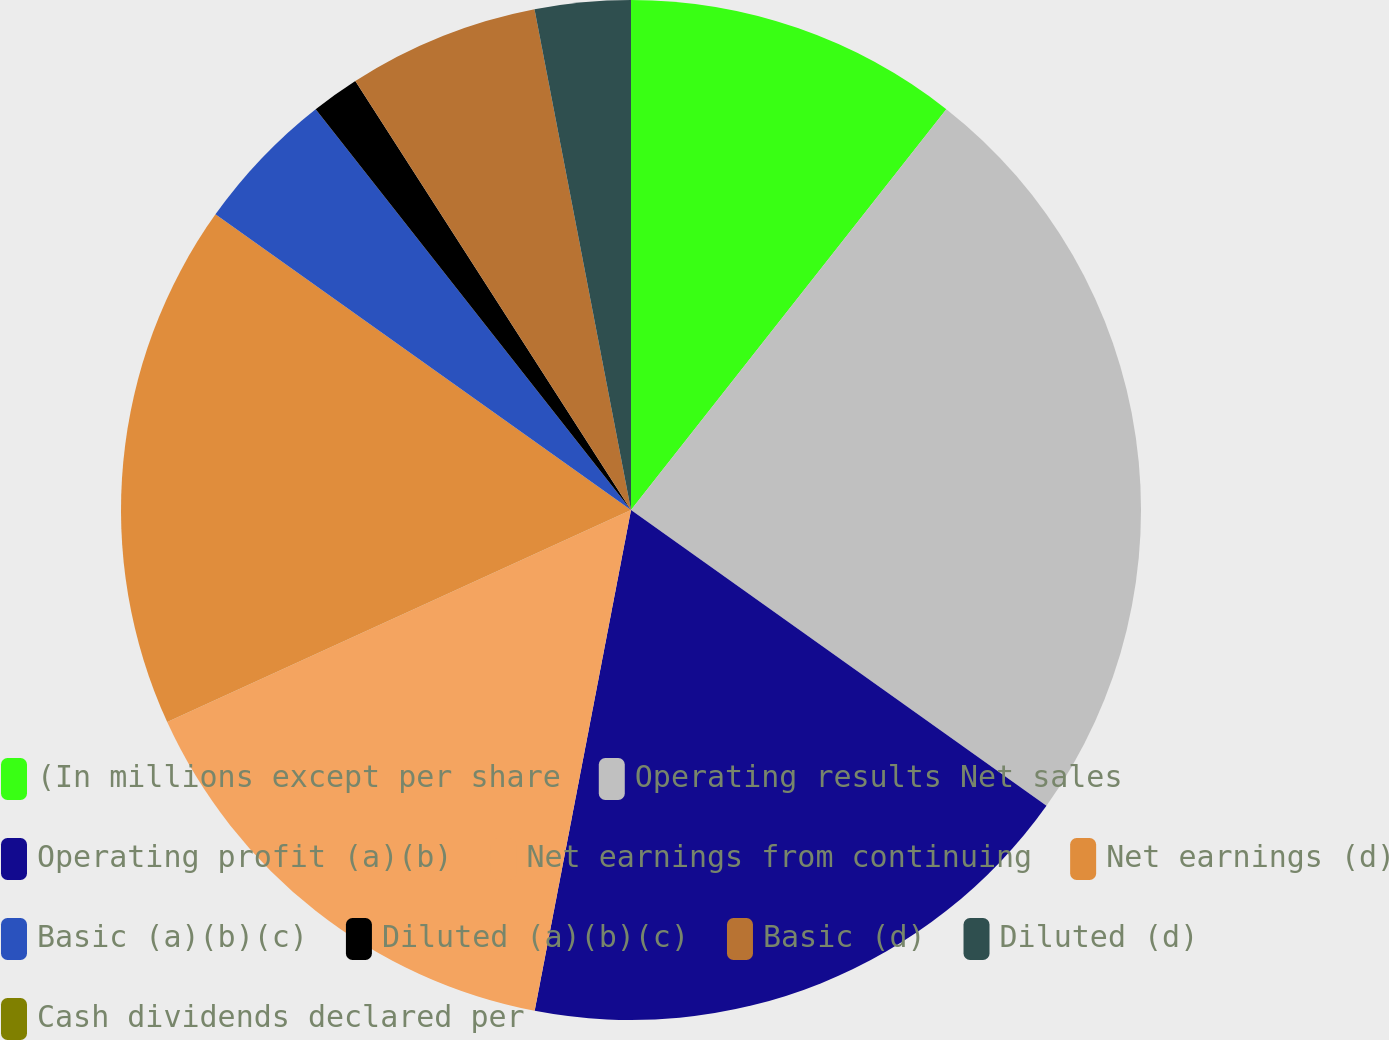<chart> <loc_0><loc_0><loc_500><loc_500><pie_chart><fcel>(In millions except per share<fcel>Operating results Net sales<fcel>Operating profit (a)(b)<fcel>Net earnings from continuing<fcel>Net earnings (d)<fcel>Basic (a)(b)(c)<fcel>Diluted (a)(b)(c)<fcel>Basic (d)<fcel>Diluted (d)<fcel>Cash dividends declared per<nl><fcel>10.61%<fcel>24.24%<fcel>18.18%<fcel>15.15%<fcel>16.67%<fcel>4.55%<fcel>1.52%<fcel>6.06%<fcel>3.03%<fcel>0.0%<nl></chart> 